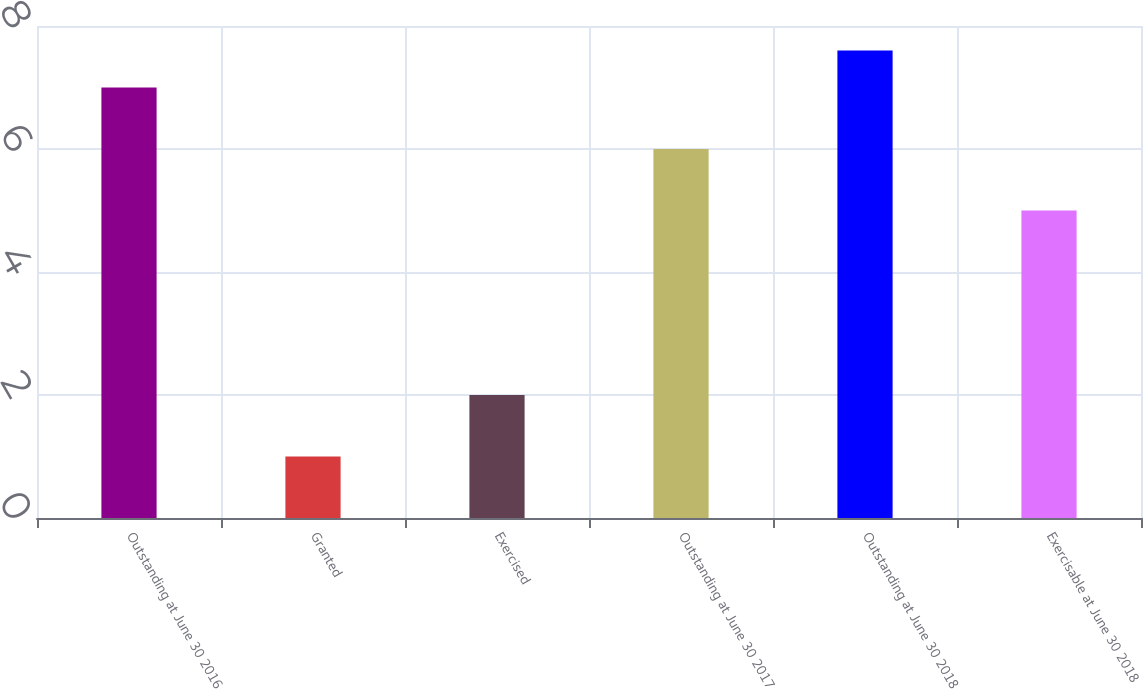Convert chart. <chart><loc_0><loc_0><loc_500><loc_500><bar_chart><fcel>Outstanding at June 30 2016<fcel>Granted<fcel>Exercised<fcel>Outstanding at June 30 2017<fcel>Outstanding at June 30 2018<fcel>Exercisable at June 30 2018<nl><fcel>7<fcel>1<fcel>2<fcel>6<fcel>7.6<fcel>5<nl></chart> 